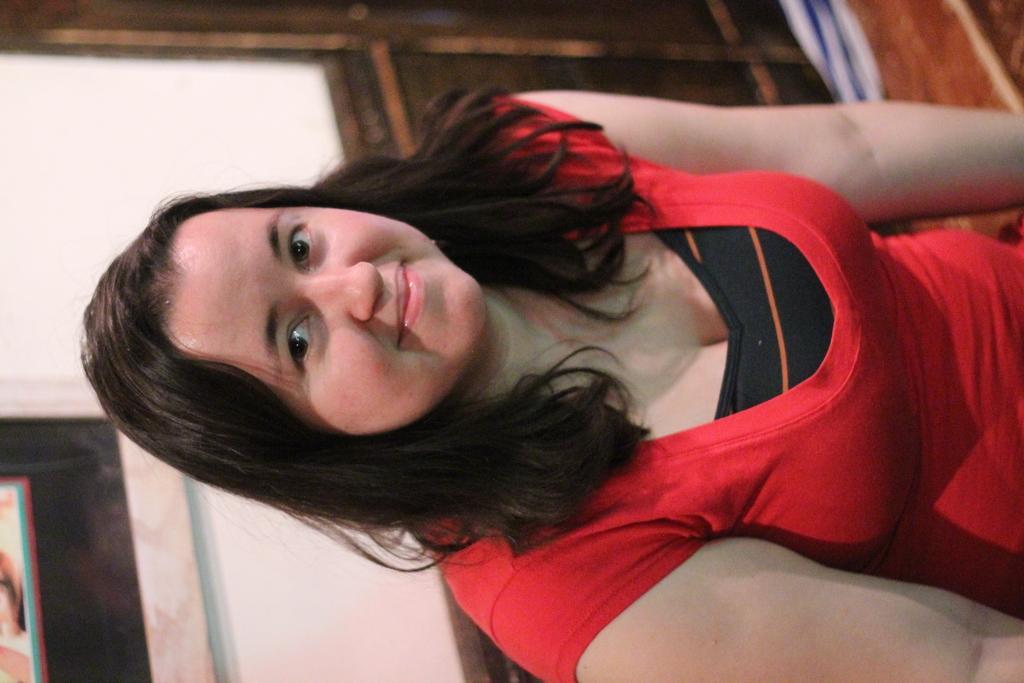Can you describe this image briefly? This image is in left direction. In this image I can see a woman wearing a red color t-shirt, smiling and looking at the picture. At the top of the image there is a wooden object. In the bottom left-hand corner there is a frame attached to the wall. 